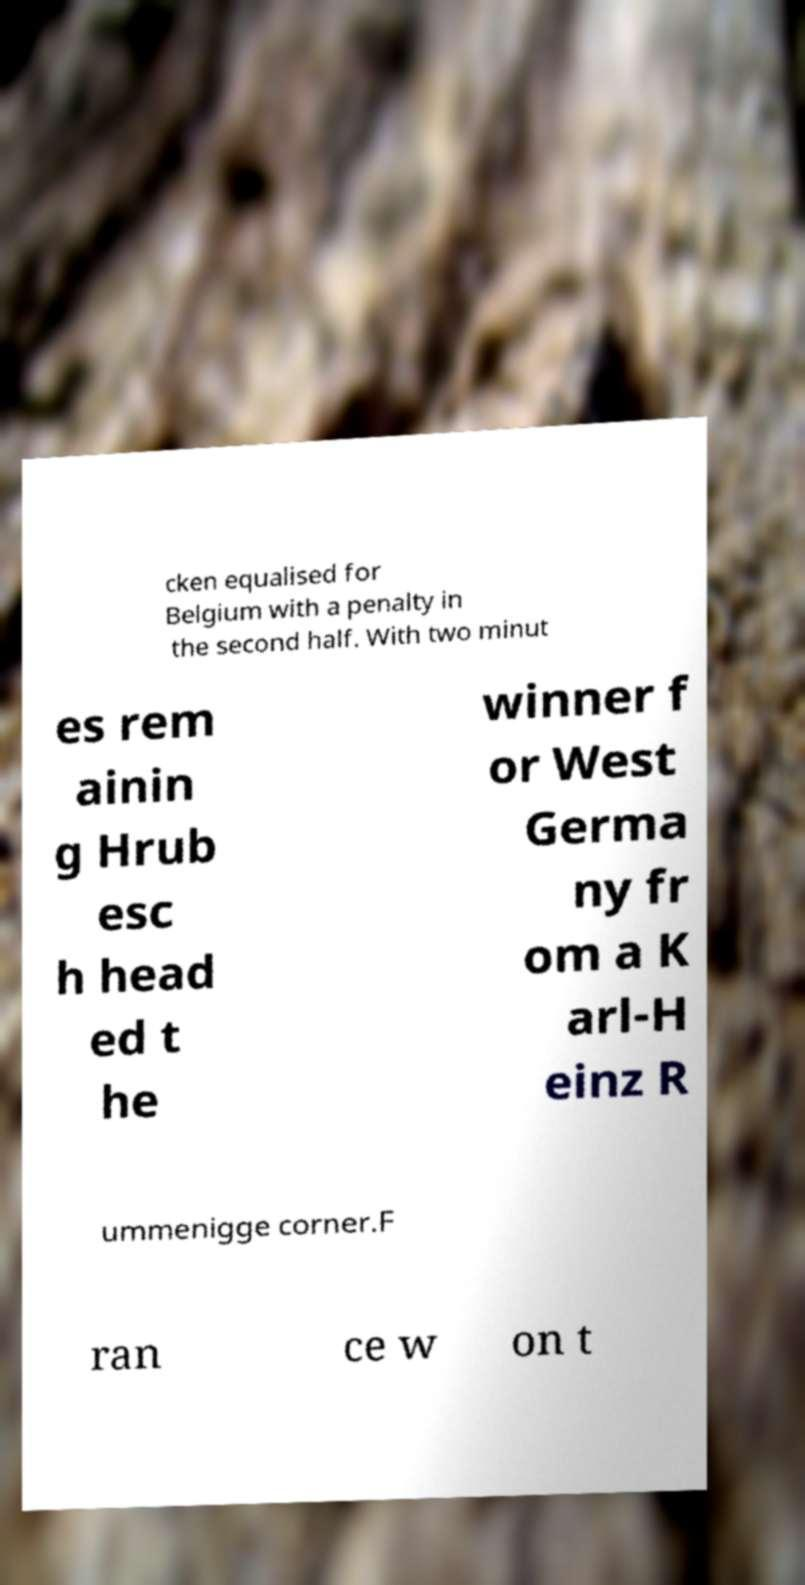What messages or text are displayed in this image? I need them in a readable, typed format. cken equalised for Belgium with a penalty in the second half. With two minut es rem ainin g Hrub esc h head ed t he winner f or West Germa ny fr om a K arl-H einz R ummenigge corner.F ran ce w on t 